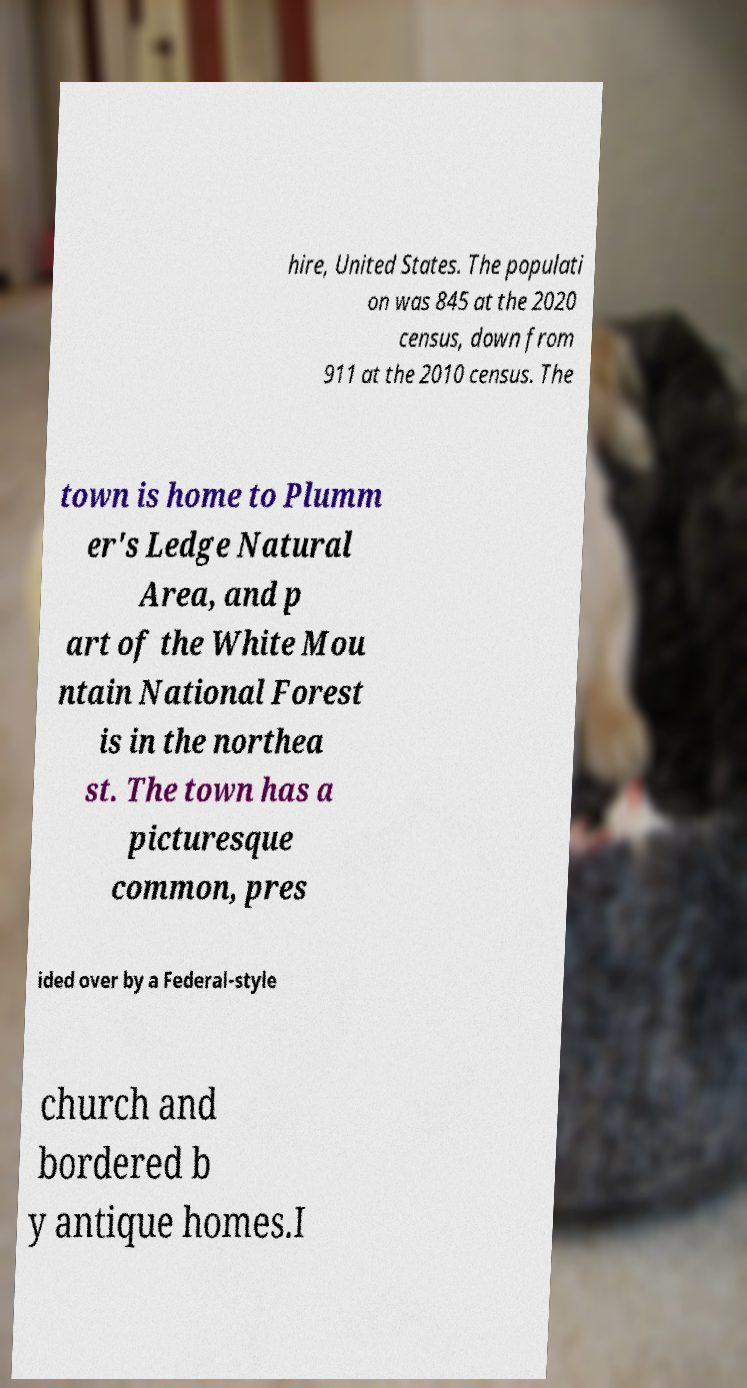Could you assist in decoding the text presented in this image and type it out clearly? hire, United States. The populati on was 845 at the 2020 census, down from 911 at the 2010 census. The town is home to Plumm er's Ledge Natural Area, and p art of the White Mou ntain National Forest is in the northea st. The town has a picturesque common, pres ided over by a Federal-style church and bordered b y antique homes.I 